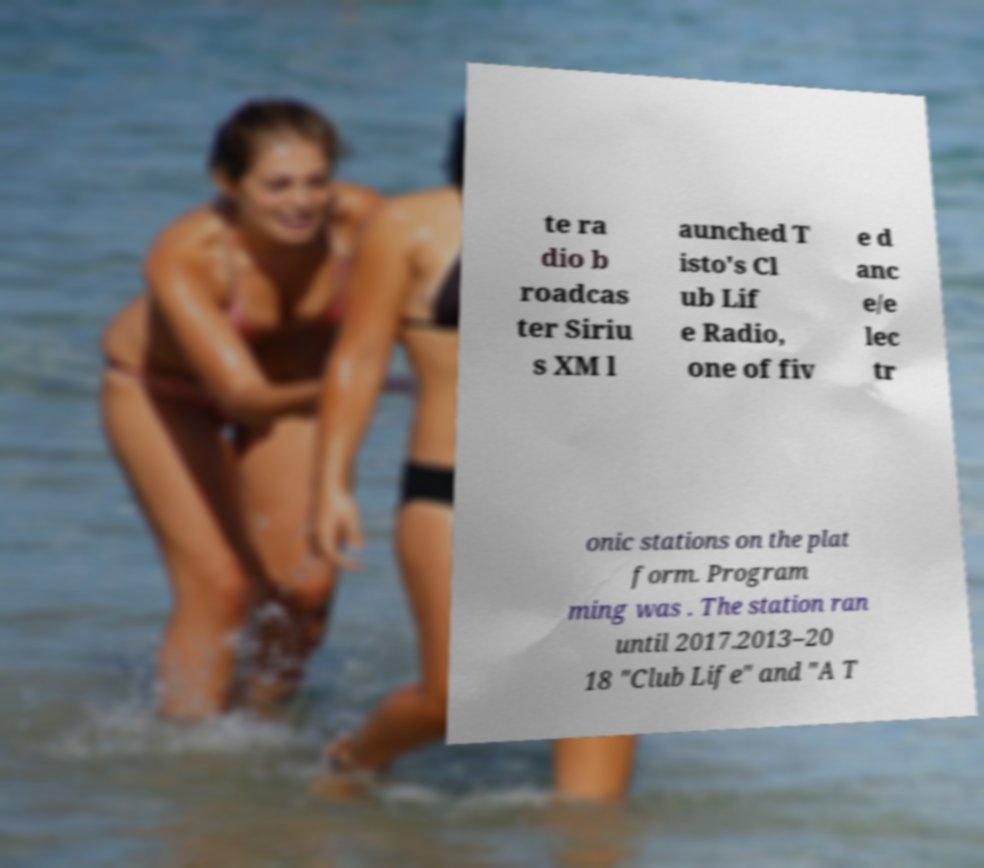Can you read and provide the text displayed in the image?This photo seems to have some interesting text. Can you extract and type it out for me? te ra dio b roadcas ter Siriu s XM l aunched T isto's Cl ub Lif e Radio, one of fiv e d anc e/e lec tr onic stations on the plat form. Program ming was . The station ran until 2017.2013–20 18 "Club Life" and "A T 